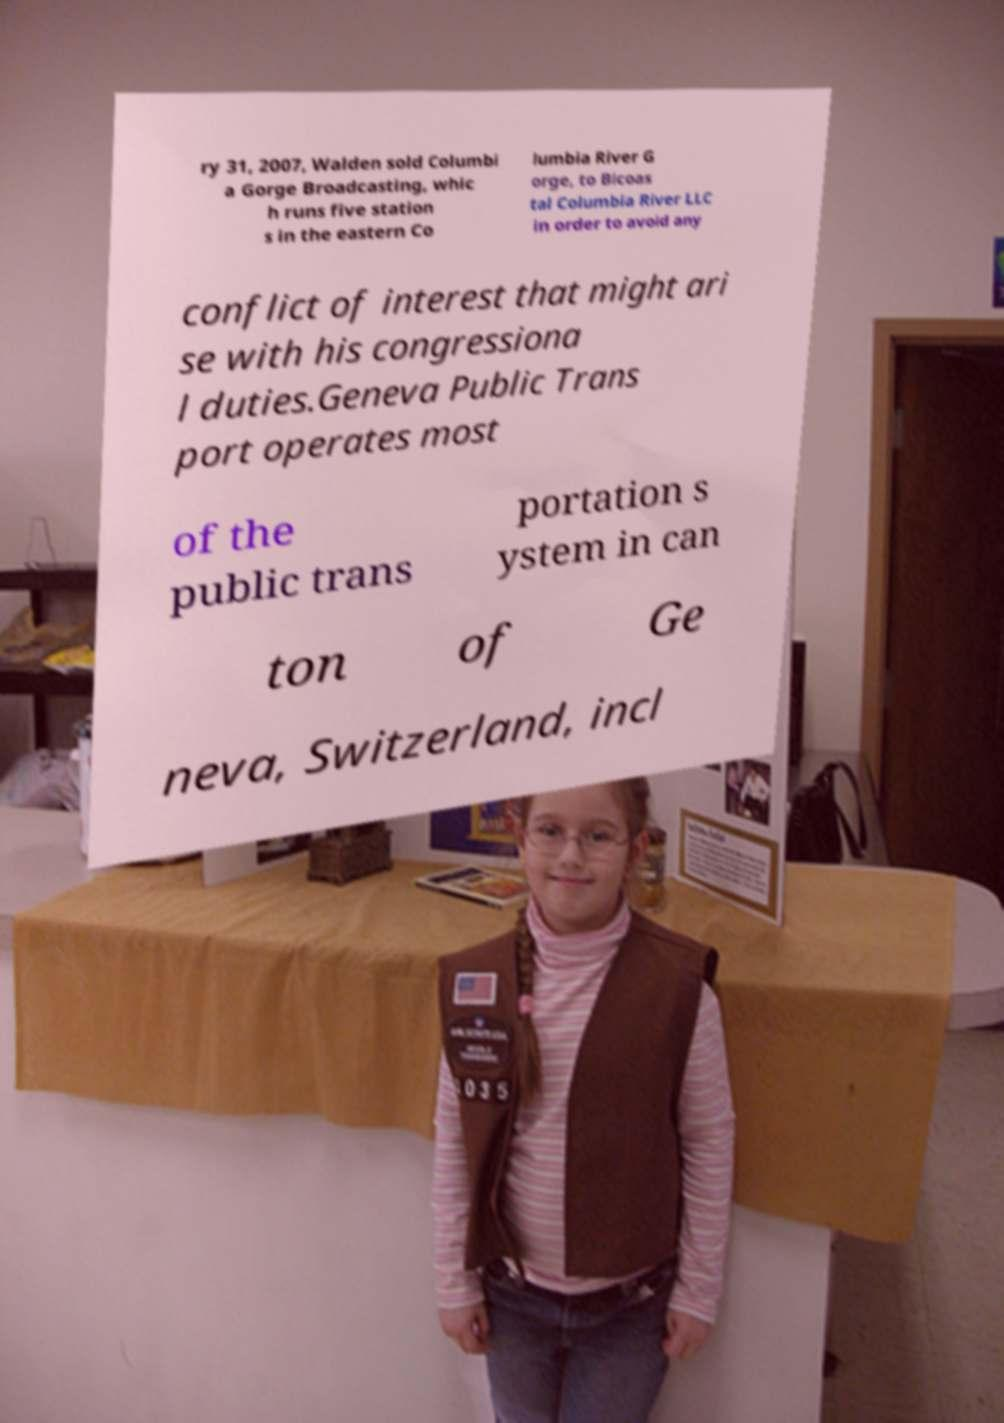Can you read and provide the text displayed in the image?This photo seems to have some interesting text. Can you extract and type it out for me? ry 31, 2007, Walden sold Columbi a Gorge Broadcasting, whic h runs five station s in the eastern Co lumbia River G orge, to Bicoas tal Columbia River LLC in order to avoid any conflict of interest that might ari se with his congressiona l duties.Geneva Public Trans port operates most of the public trans portation s ystem in can ton of Ge neva, Switzerland, incl 